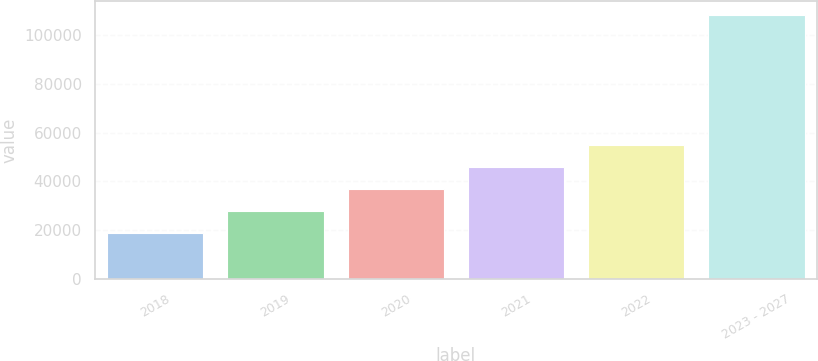Convert chart to OTSL. <chart><loc_0><loc_0><loc_500><loc_500><bar_chart><fcel>2018<fcel>2019<fcel>2020<fcel>2021<fcel>2022<fcel>2023 - 2027<nl><fcel>18962<fcel>27894.8<fcel>36827.6<fcel>45760.4<fcel>54693.2<fcel>108290<nl></chart> 